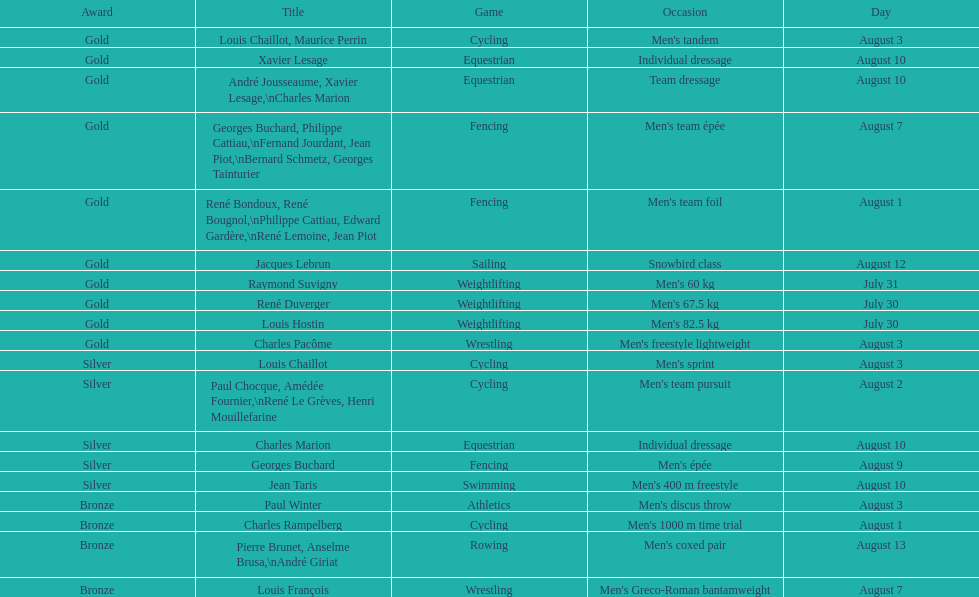What sport did louis challiot win the same medal as paul chocque in? Cycling. I'm looking to parse the entire table for insights. Could you assist me with that? {'header': ['Award', 'Title', 'Game', 'Occasion', 'Day'], 'rows': [['Gold', 'Louis Chaillot, Maurice Perrin', 'Cycling', "Men's tandem", 'August 3'], ['Gold', 'Xavier Lesage', 'Equestrian', 'Individual dressage', 'August 10'], ['Gold', 'André Jousseaume, Xavier Lesage,\\nCharles Marion', 'Equestrian', 'Team dressage', 'August 10'], ['Gold', 'Georges Buchard, Philippe Cattiau,\\nFernand Jourdant, Jean Piot,\\nBernard Schmetz, Georges Tainturier', 'Fencing', "Men's team épée", 'August 7'], ['Gold', 'René Bondoux, René Bougnol,\\nPhilippe Cattiau, Edward Gardère,\\nRené Lemoine, Jean Piot', 'Fencing', "Men's team foil", 'August 1'], ['Gold', 'Jacques Lebrun', 'Sailing', 'Snowbird class', 'August 12'], ['Gold', 'Raymond Suvigny', 'Weightlifting', "Men's 60 kg", 'July 31'], ['Gold', 'René Duverger', 'Weightlifting', "Men's 67.5 kg", 'July 30'], ['Gold', 'Louis Hostin', 'Weightlifting', "Men's 82.5 kg", 'July 30'], ['Gold', 'Charles Pacôme', 'Wrestling', "Men's freestyle lightweight", 'August 3'], ['Silver', 'Louis Chaillot', 'Cycling', "Men's sprint", 'August 3'], ['Silver', 'Paul Chocque, Amédée Fournier,\\nRené Le Grèves, Henri Mouillefarine', 'Cycling', "Men's team pursuit", 'August 2'], ['Silver', 'Charles Marion', 'Equestrian', 'Individual dressage', 'August 10'], ['Silver', 'Georges Buchard', 'Fencing', "Men's épée", 'August 9'], ['Silver', 'Jean Taris', 'Swimming', "Men's 400 m freestyle", 'August 10'], ['Bronze', 'Paul Winter', 'Athletics', "Men's discus throw", 'August 3'], ['Bronze', 'Charles Rampelberg', 'Cycling', "Men's 1000 m time trial", 'August 1'], ['Bronze', 'Pierre Brunet, Anselme Brusa,\\nAndré Giriat', 'Rowing', "Men's coxed pair", 'August 13'], ['Bronze', 'Louis François', 'Wrestling', "Men's Greco-Roman bantamweight", 'August 7']]} 